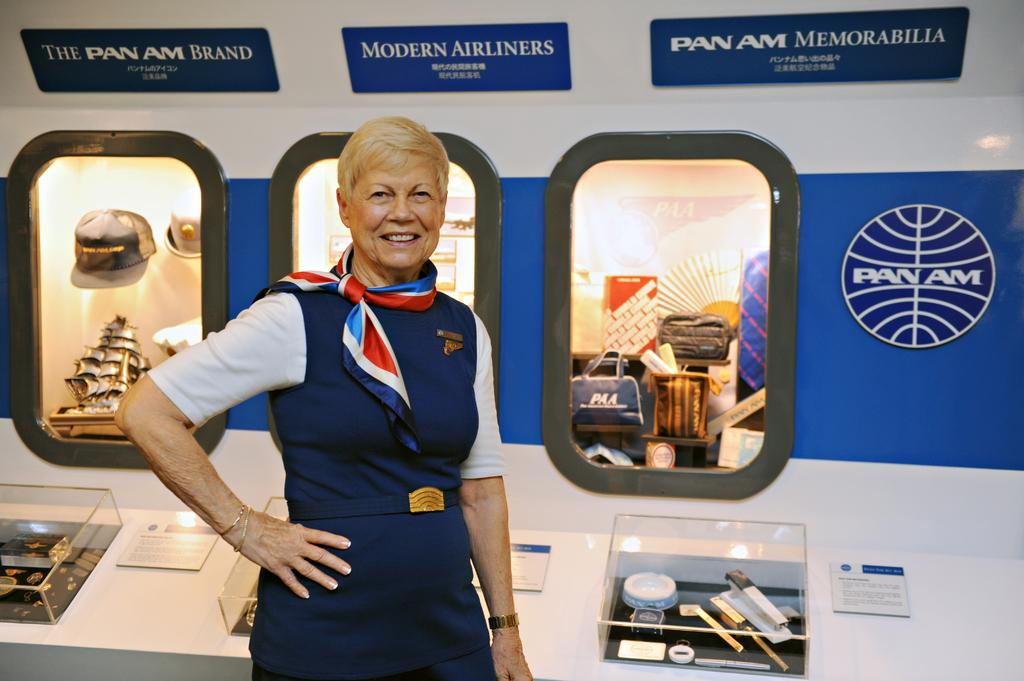<image>
Create a compact narrative representing the image presented. A flight attending is standing by a display that says Pan Am Memorabilia. 